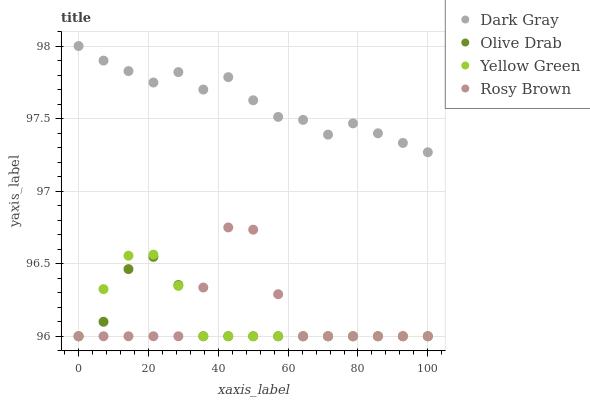Does Olive Drab have the minimum area under the curve?
Answer yes or no. Yes. Does Dark Gray have the maximum area under the curve?
Answer yes or no. Yes. Does Rosy Brown have the minimum area under the curve?
Answer yes or no. No. Does Rosy Brown have the maximum area under the curve?
Answer yes or no. No. Is Yellow Green the smoothest?
Answer yes or no. Yes. Is Rosy Brown the roughest?
Answer yes or no. Yes. Is Rosy Brown the smoothest?
Answer yes or no. No. Is Yellow Green the roughest?
Answer yes or no. No. Does Rosy Brown have the lowest value?
Answer yes or no. Yes. Does Dark Gray have the highest value?
Answer yes or no. Yes. Does Rosy Brown have the highest value?
Answer yes or no. No. Is Yellow Green less than Dark Gray?
Answer yes or no. Yes. Is Dark Gray greater than Olive Drab?
Answer yes or no. Yes. Does Olive Drab intersect Rosy Brown?
Answer yes or no. Yes. Is Olive Drab less than Rosy Brown?
Answer yes or no. No. Is Olive Drab greater than Rosy Brown?
Answer yes or no. No. Does Yellow Green intersect Dark Gray?
Answer yes or no. No. 